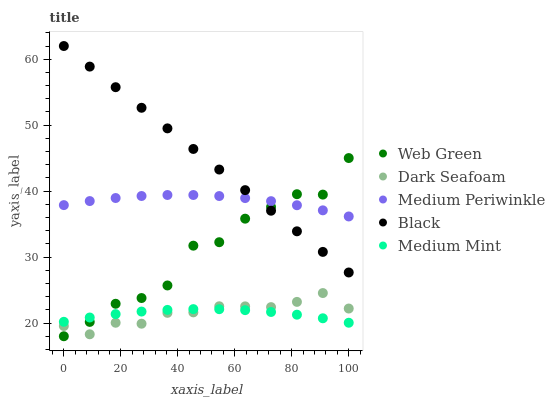Does Medium Mint have the minimum area under the curve?
Answer yes or no. Yes. Does Black have the maximum area under the curve?
Answer yes or no. Yes. Does Dark Seafoam have the minimum area under the curve?
Answer yes or no. No. Does Dark Seafoam have the maximum area under the curve?
Answer yes or no. No. Is Black the smoothest?
Answer yes or no. Yes. Is Web Green the roughest?
Answer yes or no. Yes. Is Dark Seafoam the smoothest?
Answer yes or no. No. Is Dark Seafoam the roughest?
Answer yes or no. No. Does Web Green have the lowest value?
Answer yes or no. Yes. Does Black have the lowest value?
Answer yes or no. No. Does Black have the highest value?
Answer yes or no. Yes. Does Dark Seafoam have the highest value?
Answer yes or no. No. Is Medium Mint less than Medium Periwinkle?
Answer yes or no. Yes. Is Medium Periwinkle greater than Dark Seafoam?
Answer yes or no. Yes. Does Dark Seafoam intersect Web Green?
Answer yes or no. Yes. Is Dark Seafoam less than Web Green?
Answer yes or no. No. Is Dark Seafoam greater than Web Green?
Answer yes or no. No. Does Medium Mint intersect Medium Periwinkle?
Answer yes or no. No. 